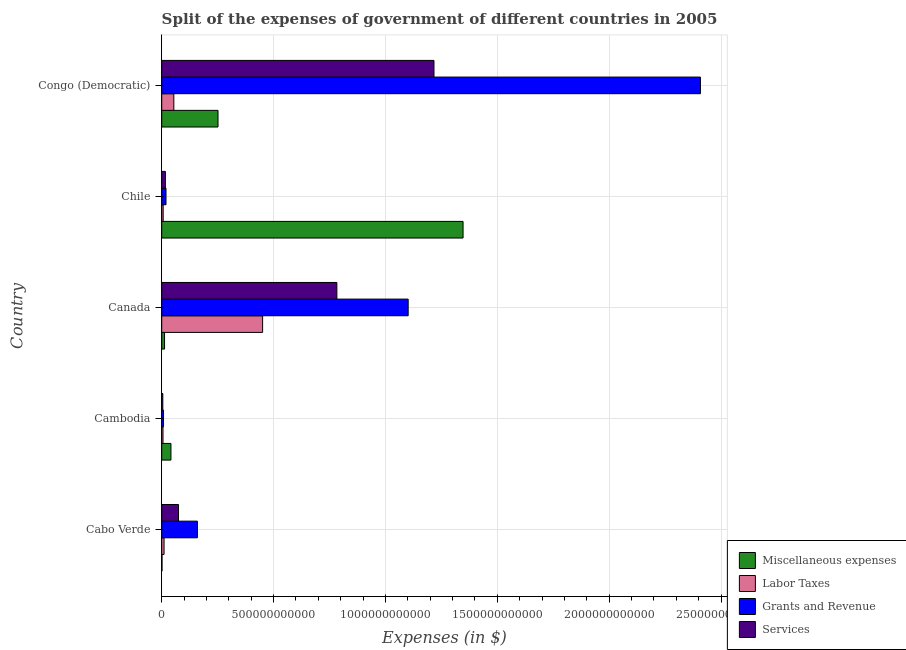How many different coloured bars are there?
Your answer should be very brief. 4. How many bars are there on the 3rd tick from the top?
Keep it short and to the point. 4. How many bars are there on the 3rd tick from the bottom?
Your answer should be very brief. 4. In how many cases, is the number of bars for a given country not equal to the number of legend labels?
Ensure brevity in your answer.  0. What is the amount spent on services in Chile?
Provide a succinct answer. 1.66e+1. Across all countries, what is the maximum amount spent on labor taxes?
Your answer should be compact. 4.51e+11. Across all countries, what is the minimum amount spent on grants and revenue?
Provide a short and direct response. 8.06e+09. In which country was the amount spent on grants and revenue maximum?
Provide a succinct answer. Congo (Democratic). In which country was the amount spent on miscellaneous expenses minimum?
Keep it short and to the point. Cabo Verde. What is the total amount spent on services in the graph?
Offer a terse response. 2.10e+12. What is the difference between the amount spent on grants and revenue in Canada and that in Congo (Democratic)?
Your answer should be compact. -1.31e+12. What is the difference between the amount spent on miscellaneous expenses in Canada and the amount spent on grants and revenue in Cabo Verde?
Your response must be concise. -1.47e+11. What is the average amount spent on labor taxes per country?
Offer a terse response. 1.06e+11. What is the difference between the amount spent on miscellaneous expenses and amount spent on grants and revenue in Cabo Verde?
Provide a succinct answer. -1.58e+11. What is the ratio of the amount spent on grants and revenue in Cambodia to that in Congo (Democratic)?
Keep it short and to the point. 0. Is the amount spent on grants and revenue in Cabo Verde less than that in Congo (Democratic)?
Provide a succinct answer. Yes. Is the difference between the amount spent on labor taxes in Cabo Verde and Congo (Democratic) greater than the difference between the amount spent on services in Cabo Verde and Congo (Democratic)?
Ensure brevity in your answer.  Yes. What is the difference between the highest and the second highest amount spent on miscellaneous expenses?
Your response must be concise. 1.10e+12. What is the difference between the highest and the lowest amount spent on miscellaneous expenses?
Your response must be concise. 1.35e+12. What does the 1st bar from the top in Cabo Verde represents?
Provide a succinct answer. Services. What does the 3rd bar from the bottom in Cambodia represents?
Provide a succinct answer. Grants and Revenue. How many bars are there?
Offer a very short reply. 20. Are all the bars in the graph horizontal?
Your answer should be compact. Yes. What is the difference between two consecutive major ticks on the X-axis?
Your response must be concise. 5.00e+11. Does the graph contain grids?
Offer a terse response. Yes. How many legend labels are there?
Provide a succinct answer. 4. How are the legend labels stacked?
Provide a succinct answer. Vertical. What is the title of the graph?
Provide a succinct answer. Split of the expenses of government of different countries in 2005. What is the label or title of the X-axis?
Provide a short and direct response. Expenses (in $). What is the label or title of the Y-axis?
Your answer should be very brief. Country. What is the Expenses (in $) in Miscellaneous expenses in Cabo Verde?
Offer a very short reply. 1.37e+09. What is the Expenses (in $) in Labor Taxes in Cabo Verde?
Make the answer very short. 1.05e+1. What is the Expenses (in $) of Grants and Revenue in Cabo Verde?
Ensure brevity in your answer.  1.60e+11. What is the Expenses (in $) in Services in Cabo Verde?
Ensure brevity in your answer.  7.51e+1. What is the Expenses (in $) in Miscellaneous expenses in Cambodia?
Your answer should be compact. 4.13e+1. What is the Expenses (in $) of Labor Taxes in Cambodia?
Offer a very short reply. 5.77e+09. What is the Expenses (in $) of Grants and Revenue in Cambodia?
Ensure brevity in your answer.  8.06e+09. What is the Expenses (in $) of Services in Cambodia?
Your answer should be very brief. 4.92e+09. What is the Expenses (in $) in Miscellaneous expenses in Canada?
Give a very brief answer. 1.27e+1. What is the Expenses (in $) of Labor Taxes in Canada?
Your answer should be very brief. 4.51e+11. What is the Expenses (in $) of Grants and Revenue in Canada?
Ensure brevity in your answer.  1.10e+12. What is the Expenses (in $) of Services in Canada?
Your answer should be very brief. 7.83e+11. What is the Expenses (in $) in Miscellaneous expenses in Chile?
Make the answer very short. 1.35e+12. What is the Expenses (in $) of Labor Taxes in Chile?
Offer a very short reply. 6.53e+09. What is the Expenses (in $) of Grants and Revenue in Chile?
Provide a short and direct response. 1.92e+1. What is the Expenses (in $) in Services in Chile?
Give a very brief answer. 1.66e+1. What is the Expenses (in $) in Miscellaneous expenses in Congo (Democratic)?
Offer a very short reply. 2.52e+11. What is the Expenses (in $) in Labor Taxes in Congo (Democratic)?
Give a very brief answer. 5.42e+1. What is the Expenses (in $) of Grants and Revenue in Congo (Democratic)?
Your answer should be compact. 2.41e+12. What is the Expenses (in $) in Services in Congo (Democratic)?
Ensure brevity in your answer.  1.22e+12. Across all countries, what is the maximum Expenses (in $) of Miscellaneous expenses?
Offer a terse response. 1.35e+12. Across all countries, what is the maximum Expenses (in $) of Labor Taxes?
Offer a very short reply. 4.51e+11. Across all countries, what is the maximum Expenses (in $) of Grants and Revenue?
Offer a terse response. 2.41e+12. Across all countries, what is the maximum Expenses (in $) in Services?
Provide a succinct answer. 1.22e+12. Across all countries, what is the minimum Expenses (in $) in Miscellaneous expenses?
Your response must be concise. 1.37e+09. Across all countries, what is the minimum Expenses (in $) in Labor Taxes?
Your response must be concise. 5.77e+09. Across all countries, what is the minimum Expenses (in $) in Grants and Revenue?
Keep it short and to the point. 8.06e+09. Across all countries, what is the minimum Expenses (in $) in Services?
Your response must be concise. 4.92e+09. What is the total Expenses (in $) of Miscellaneous expenses in the graph?
Give a very brief answer. 1.65e+12. What is the total Expenses (in $) of Labor Taxes in the graph?
Keep it short and to the point. 5.28e+11. What is the total Expenses (in $) of Grants and Revenue in the graph?
Ensure brevity in your answer.  3.70e+12. What is the total Expenses (in $) of Services in the graph?
Offer a terse response. 2.10e+12. What is the difference between the Expenses (in $) of Miscellaneous expenses in Cabo Verde and that in Cambodia?
Offer a very short reply. -3.99e+1. What is the difference between the Expenses (in $) of Labor Taxes in Cabo Verde and that in Cambodia?
Provide a short and direct response. 4.74e+09. What is the difference between the Expenses (in $) in Grants and Revenue in Cabo Verde and that in Cambodia?
Keep it short and to the point. 1.52e+11. What is the difference between the Expenses (in $) of Services in Cabo Verde and that in Cambodia?
Ensure brevity in your answer.  7.02e+1. What is the difference between the Expenses (in $) of Miscellaneous expenses in Cabo Verde and that in Canada?
Make the answer very short. -1.13e+1. What is the difference between the Expenses (in $) of Labor Taxes in Cabo Verde and that in Canada?
Ensure brevity in your answer.  -4.40e+11. What is the difference between the Expenses (in $) in Grants and Revenue in Cabo Verde and that in Canada?
Your response must be concise. -9.42e+11. What is the difference between the Expenses (in $) of Services in Cabo Verde and that in Canada?
Provide a short and direct response. -7.08e+11. What is the difference between the Expenses (in $) in Miscellaneous expenses in Cabo Verde and that in Chile?
Offer a very short reply. -1.35e+12. What is the difference between the Expenses (in $) in Labor Taxes in Cabo Verde and that in Chile?
Provide a short and direct response. 3.97e+09. What is the difference between the Expenses (in $) of Grants and Revenue in Cabo Verde and that in Chile?
Keep it short and to the point. 1.40e+11. What is the difference between the Expenses (in $) in Services in Cabo Verde and that in Chile?
Provide a succinct answer. 5.85e+1. What is the difference between the Expenses (in $) in Miscellaneous expenses in Cabo Verde and that in Congo (Democratic)?
Your answer should be very brief. -2.50e+11. What is the difference between the Expenses (in $) in Labor Taxes in Cabo Verde and that in Congo (Democratic)?
Ensure brevity in your answer.  -4.37e+1. What is the difference between the Expenses (in $) of Grants and Revenue in Cabo Verde and that in Congo (Democratic)?
Your response must be concise. -2.25e+12. What is the difference between the Expenses (in $) in Services in Cabo Verde and that in Congo (Democratic)?
Your answer should be compact. -1.14e+12. What is the difference between the Expenses (in $) of Miscellaneous expenses in Cambodia and that in Canada?
Provide a short and direct response. 2.86e+1. What is the difference between the Expenses (in $) of Labor Taxes in Cambodia and that in Canada?
Make the answer very short. -4.45e+11. What is the difference between the Expenses (in $) in Grants and Revenue in Cambodia and that in Canada?
Your answer should be very brief. -1.09e+12. What is the difference between the Expenses (in $) in Services in Cambodia and that in Canada?
Your response must be concise. -7.78e+11. What is the difference between the Expenses (in $) of Miscellaneous expenses in Cambodia and that in Chile?
Keep it short and to the point. -1.31e+12. What is the difference between the Expenses (in $) of Labor Taxes in Cambodia and that in Chile?
Make the answer very short. -7.62e+08. What is the difference between the Expenses (in $) of Grants and Revenue in Cambodia and that in Chile?
Offer a terse response. -1.11e+1. What is the difference between the Expenses (in $) of Services in Cambodia and that in Chile?
Your answer should be compact. -1.17e+1. What is the difference between the Expenses (in $) in Miscellaneous expenses in Cambodia and that in Congo (Democratic)?
Make the answer very short. -2.10e+11. What is the difference between the Expenses (in $) in Labor Taxes in Cambodia and that in Congo (Democratic)?
Offer a terse response. -4.84e+1. What is the difference between the Expenses (in $) in Grants and Revenue in Cambodia and that in Congo (Democratic)?
Offer a terse response. -2.40e+12. What is the difference between the Expenses (in $) of Services in Cambodia and that in Congo (Democratic)?
Provide a succinct answer. -1.21e+12. What is the difference between the Expenses (in $) of Miscellaneous expenses in Canada and that in Chile?
Your answer should be very brief. -1.33e+12. What is the difference between the Expenses (in $) of Labor Taxes in Canada and that in Chile?
Give a very brief answer. 4.44e+11. What is the difference between the Expenses (in $) in Grants and Revenue in Canada and that in Chile?
Keep it short and to the point. 1.08e+12. What is the difference between the Expenses (in $) of Services in Canada and that in Chile?
Offer a terse response. 7.66e+11. What is the difference between the Expenses (in $) in Miscellaneous expenses in Canada and that in Congo (Democratic)?
Give a very brief answer. -2.39e+11. What is the difference between the Expenses (in $) of Labor Taxes in Canada and that in Congo (Democratic)?
Ensure brevity in your answer.  3.97e+11. What is the difference between the Expenses (in $) in Grants and Revenue in Canada and that in Congo (Democratic)?
Your answer should be very brief. -1.31e+12. What is the difference between the Expenses (in $) of Services in Canada and that in Congo (Democratic)?
Your answer should be very brief. -4.34e+11. What is the difference between the Expenses (in $) of Miscellaneous expenses in Chile and that in Congo (Democratic)?
Your answer should be very brief. 1.10e+12. What is the difference between the Expenses (in $) in Labor Taxes in Chile and that in Congo (Democratic)?
Offer a very short reply. -4.76e+1. What is the difference between the Expenses (in $) of Grants and Revenue in Chile and that in Congo (Democratic)?
Offer a terse response. -2.39e+12. What is the difference between the Expenses (in $) in Services in Chile and that in Congo (Democratic)?
Offer a terse response. -1.20e+12. What is the difference between the Expenses (in $) of Miscellaneous expenses in Cabo Verde and the Expenses (in $) of Labor Taxes in Cambodia?
Offer a terse response. -4.40e+09. What is the difference between the Expenses (in $) in Miscellaneous expenses in Cabo Verde and the Expenses (in $) in Grants and Revenue in Cambodia?
Your response must be concise. -6.69e+09. What is the difference between the Expenses (in $) in Miscellaneous expenses in Cabo Verde and the Expenses (in $) in Services in Cambodia?
Offer a terse response. -3.54e+09. What is the difference between the Expenses (in $) of Labor Taxes in Cabo Verde and the Expenses (in $) of Grants and Revenue in Cambodia?
Give a very brief answer. 2.44e+09. What is the difference between the Expenses (in $) of Labor Taxes in Cabo Verde and the Expenses (in $) of Services in Cambodia?
Make the answer very short. 5.59e+09. What is the difference between the Expenses (in $) of Grants and Revenue in Cabo Verde and the Expenses (in $) of Services in Cambodia?
Your answer should be very brief. 1.55e+11. What is the difference between the Expenses (in $) of Miscellaneous expenses in Cabo Verde and the Expenses (in $) of Labor Taxes in Canada?
Make the answer very short. -4.50e+11. What is the difference between the Expenses (in $) of Miscellaneous expenses in Cabo Verde and the Expenses (in $) of Grants and Revenue in Canada?
Your answer should be very brief. -1.10e+12. What is the difference between the Expenses (in $) in Miscellaneous expenses in Cabo Verde and the Expenses (in $) in Services in Canada?
Offer a terse response. -7.82e+11. What is the difference between the Expenses (in $) in Labor Taxes in Cabo Verde and the Expenses (in $) in Grants and Revenue in Canada?
Provide a succinct answer. -1.09e+12. What is the difference between the Expenses (in $) in Labor Taxes in Cabo Verde and the Expenses (in $) in Services in Canada?
Your answer should be very brief. -7.72e+11. What is the difference between the Expenses (in $) in Grants and Revenue in Cabo Verde and the Expenses (in $) in Services in Canada?
Offer a terse response. -6.23e+11. What is the difference between the Expenses (in $) of Miscellaneous expenses in Cabo Verde and the Expenses (in $) of Labor Taxes in Chile?
Your answer should be very brief. -5.16e+09. What is the difference between the Expenses (in $) of Miscellaneous expenses in Cabo Verde and the Expenses (in $) of Grants and Revenue in Chile?
Your answer should be very brief. -1.78e+1. What is the difference between the Expenses (in $) in Miscellaneous expenses in Cabo Verde and the Expenses (in $) in Services in Chile?
Offer a very short reply. -1.52e+1. What is the difference between the Expenses (in $) in Labor Taxes in Cabo Verde and the Expenses (in $) in Grants and Revenue in Chile?
Ensure brevity in your answer.  -8.68e+09. What is the difference between the Expenses (in $) of Labor Taxes in Cabo Verde and the Expenses (in $) of Services in Chile?
Your answer should be very brief. -6.10e+09. What is the difference between the Expenses (in $) in Grants and Revenue in Cabo Verde and the Expenses (in $) in Services in Chile?
Provide a succinct answer. 1.43e+11. What is the difference between the Expenses (in $) in Miscellaneous expenses in Cabo Verde and the Expenses (in $) in Labor Taxes in Congo (Democratic)?
Provide a succinct answer. -5.28e+1. What is the difference between the Expenses (in $) of Miscellaneous expenses in Cabo Verde and the Expenses (in $) of Grants and Revenue in Congo (Democratic)?
Make the answer very short. -2.41e+12. What is the difference between the Expenses (in $) in Miscellaneous expenses in Cabo Verde and the Expenses (in $) in Services in Congo (Democratic)?
Provide a succinct answer. -1.22e+12. What is the difference between the Expenses (in $) in Labor Taxes in Cabo Verde and the Expenses (in $) in Grants and Revenue in Congo (Democratic)?
Offer a terse response. -2.40e+12. What is the difference between the Expenses (in $) in Labor Taxes in Cabo Verde and the Expenses (in $) in Services in Congo (Democratic)?
Your answer should be very brief. -1.21e+12. What is the difference between the Expenses (in $) in Grants and Revenue in Cabo Verde and the Expenses (in $) in Services in Congo (Democratic)?
Keep it short and to the point. -1.06e+12. What is the difference between the Expenses (in $) of Miscellaneous expenses in Cambodia and the Expenses (in $) of Labor Taxes in Canada?
Your answer should be compact. -4.10e+11. What is the difference between the Expenses (in $) of Miscellaneous expenses in Cambodia and the Expenses (in $) of Grants and Revenue in Canada?
Your response must be concise. -1.06e+12. What is the difference between the Expenses (in $) of Miscellaneous expenses in Cambodia and the Expenses (in $) of Services in Canada?
Provide a short and direct response. -7.42e+11. What is the difference between the Expenses (in $) of Labor Taxes in Cambodia and the Expenses (in $) of Grants and Revenue in Canada?
Keep it short and to the point. -1.10e+12. What is the difference between the Expenses (in $) in Labor Taxes in Cambodia and the Expenses (in $) in Services in Canada?
Make the answer very short. -7.77e+11. What is the difference between the Expenses (in $) of Grants and Revenue in Cambodia and the Expenses (in $) of Services in Canada?
Provide a succinct answer. -7.75e+11. What is the difference between the Expenses (in $) in Miscellaneous expenses in Cambodia and the Expenses (in $) in Labor Taxes in Chile?
Your response must be concise. 3.47e+1. What is the difference between the Expenses (in $) in Miscellaneous expenses in Cambodia and the Expenses (in $) in Grants and Revenue in Chile?
Give a very brief answer. 2.21e+1. What is the difference between the Expenses (in $) in Miscellaneous expenses in Cambodia and the Expenses (in $) in Services in Chile?
Make the answer very short. 2.47e+1. What is the difference between the Expenses (in $) in Labor Taxes in Cambodia and the Expenses (in $) in Grants and Revenue in Chile?
Your answer should be very brief. -1.34e+1. What is the difference between the Expenses (in $) in Labor Taxes in Cambodia and the Expenses (in $) in Services in Chile?
Your answer should be compact. -1.08e+1. What is the difference between the Expenses (in $) in Grants and Revenue in Cambodia and the Expenses (in $) in Services in Chile?
Ensure brevity in your answer.  -8.54e+09. What is the difference between the Expenses (in $) in Miscellaneous expenses in Cambodia and the Expenses (in $) in Labor Taxes in Congo (Democratic)?
Offer a terse response. -1.29e+1. What is the difference between the Expenses (in $) of Miscellaneous expenses in Cambodia and the Expenses (in $) of Grants and Revenue in Congo (Democratic)?
Your answer should be compact. -2.37e+12. What is the difference between the Expenses (in $) in Miscellaneous expenses in Cambodia and the Expenses (in $) in Services in Congo (Democratic)?
Provide a succinct answer. -1.18e+12. What is the difference between the Expenses (in $) in Labor Taxes in Cambodia and the Expenses (in $) in Grants and Revenue in Congo (Democratic)?
Your response must be concise. -2.40e+12. What is the difference between the Expenses (in $) of Labor Taxes in Cambodia and the Expenses (in $) of Services in Congo (Democratic)?
Offer a terse response. -1.21e+12. What is the difference between the Expenses (in $) of Grants and Revenue in Cambodia and the Expenses (in $) of Services in Congo (Democratic)?
Ensure brevity in your answer.  -1.21e+12. What is the difference between the Expenses (in $) in Miscellaneous expenses in Canada and the Expenses (in $) in Labor Taxes in Chile?
Your response must be concise. 6.17e+09. What is the difference between the Expenses (in $) of Miscellaneous expenses in Canada and the Expenses (in $) of Grants and Revenue in Chile?
Your answer should be compact. -6.48e+09. What is the difference between the Expenses (in $) of Miscellaneous expenses in Canada and the Expenses (in $) of Services in Chile?
Offer a very short reply. -3.91e+09. What is the difference between the Expenses (in $) of Labor Taxes in Canada and the Expenses (in $) of Grants and Revenue in Chile?
Provide a succinct answer. 4.32e+11. What is the difference between the Expenses (in $) in Labor Taxes in Canada and the Expenses (in $) in Services in Chile?
Your answer should be compact. 4.34e+11. What is the difference between the Expenses (in $) of Grants and Revenue in Canada and the Expenses (in $) of Services in Chile?
Make the answer very short. 1.09e+12. What is the difference between the Expenses (in $) in Miscellaneous expenses in Canada and the Expenses (in $) in Labor Taxes in Congo (Democratic)?
Offer a very short reply. -4.15e+1. What is the difference between the Expenses (in $) of Miscellaneous expenses in Canada and the Expenses (in $) of Grants and Revenue in Congo (Democratic)?
Make the answer very short. -2.40e+12. What is the difference between the Expenses (in $) of Miscellaneous expenses in Canada and the Expenses (in $) of Services in Congo (Democratic)?
Your answer should be compact. -1.20e+12. What is the difference between the Expenses (in $) in Labor Taxes in Canada and the Expenses (in $) in Grants and Revenue in Congo (Democratic)?
Your response must be concise. -1.96e+12. What is the difference between the Expenses (in $) of Labor Taxes in Canada and the Expenses (in $) of Services in Congo (Democratic)?
Provide a succinct answer. -7.66e+11. What is the difference between the Expenses (in $) in Grants and Revenue in Canada and the Expenses (in $) in Services in Congo (Democratic)?
Your answer should be compact. -1.15e+11. What is the difference between the Expenses (in $) in Miscellaneous expenses in Chile and the Expenses (in $) in Labor Taxes in Congo (Democratic)?
Ensure brevity in your answer.  1.29e+12. What is the difference between the Expenses (in $) of Miscellaneous expenses in Chile and the Expenses (in $) of Grants and Revenue in Congo (Democratic)?
Offer a very short reply. -1.06e+12. What is the difference between the Expenses (in $) in Miscellaneous expenses in Chile and the Expenses (in $) in Services in Congo (Democratic)?
Keep it short and to the point. 1.30e+11. What is the difference between the Expenses (in $) in Labor Taxes in Chile and the Expenses (in $) in Grants and Revenue in Congo (Democratic)?
Offer a terse response. -2.40e+12. What is the difference between the Expenses (in $) in Labor Taxes in Chile and the Expenses (in $) in Services in Congo (Democratic)?
Offer a terse response. -1.21e+12. What is the difference between the Expenses (in $) of Grants and Revenue in Chile and the Expenses (in $) of Services in Congo (Democratic)?
Offer a very short reply. -1.20e+12. What is the average Expenses (in $) in Miscellaneous expenses per country?
Give a very brief answer. 3.31e+11. What is the average Expenses (in $) of Labor Taxes per country?
Your answer should be compact. 1.06e+11. What is the average Expenses (in $) of Grants and Revenue per country?
Your answer should be very brief. 7.39e+11. What is the average Expenses (in $) in Services per country?
Your answer should be very brief. 4.19e+11. What is the difference between the Expenses (in $) of Miscellaneous expenses and Expenses (in $) of Labor Taxes in Cabo Verde?
Offer a very short reply. -9.13e+09. What is the difference between the Expenses (in $) of Miscellaneous expenses and Expenses (in $) of Grants and Revenue in Cabo Verde?
Offer a very short reply. -1.58e+11. What is the difference between the Expenses (in $) of Miscellaneous expenses and Expenses (in $) of Services in Cabo Verde?
Give a very brief answer. -7.37e+1. What is the difference between the Expenses (in $) of Labor Taxes and Expenses (in $) of Grants and Revenue in Cabo Verde?
Give a very brief answer. -1.49e+11. What is the difference between the Expenses (in $) in Labor Taxes and Expenses (in $) in Services in Cabo Verde?
Provide a short and direct response. -6.46e+1. What is the difference between the Expenses (in $) of Grants and Revenue and Expenses (in $) of Services in Cabo Verde?
Give a very brief answer. 8.45e+1. What is the difference between the Expenses (in $) in Miscellaneous expenses and Expenses (in $) in Labor Taxes in Cambodia?
Your answer should be very brief. 3.55e+1. What is the difference between the Expenses (in $) of Miscellaneous expenses and Expenses (in $) of Grants and Revenue in Cambodia?
Provide a succinct answer. 3.32e+1. What is the difference between the Expenses (in $) in Miscellaneous expenses and Expenses (in $) in Services in Cambodia?
Offer a terse response. 3.64e+1. What is the difference between the Expenses (in $) in Labor Taxes and Expenses (in $) in Grants and Revenue in Cambodia?
Keep it short and to the point. -2.30e+09. What is the difference between the Expenses (in $) of Labor Taxes and Expenses (in $) of Services in Cambodia?
Provide a short and direct response. 8.52e+08. What is the difference between the Expenses (in $) in Grants and Revenue and Expenses (in $) in Services in Cambodia?
Keep it short and to the point. 3.15e+09. What is the difference between the Expenses (in $) in Miscellaneous expenses and Expenses (in $) in Labor Taxes in Canada?
Keep it short and to the point. -4.38e+11. What is the difference between the Expenses (in $) of Miscellaneous expenses and Expenses (in $) of Grants and Revenue in Canada?
Your answer should be compact. -1.09e+12. What is the difference between the Expenses (in $) in Miscellaneous expenses and Expenses (in $) in Services in Canada?
Offer a very short reply. -7.70e+11. What is the difference between the Expenses (in $) in Labor Taxes and Expenses (in $) in Grants and Revenue in Canada?
Your response must be concise. -6.51e+11. What is the difference between the Expenses (in $) in Labor Taxes and Expenses (in $) in Services in Canada?
Your response must be concise. -3.32e+11. What is the difference between the Expenses (in $) of Grants and Revenue and Expenses (in $) of Services in Canada?
Provide a succinct answer. 3.19e+11. What is the difference between the Expenses (in $) in Miscellaneous expenses and Expenses (in $) in Labor Taxes in Chile?
Keep it short and to the point. 1.34e+12. What is the difference between the Expenses (in $) of Miscellaneous expenses and Expenses (in $) of Grants and Revenue in Chile?
Your response must be concise. 1.33e+12. What is the difference between the Expenses (in $) in Miscellaneous expenses and Expenses (in $) in Services in Chile?
Your response must be concise. 1.33e+12. What is the difference between the Expenses (in $) of Labor Taxes and Expenses (in $) of Grants and Revenue in Chile?
Ensure brevity in your answer.  -1.27e+1. What is the difference between the Expenses (in $) in Labor Taxes and Expenses (in $) in Services in Chile?
Give a very brief answer. -1.01e+1. What is the difference between the Expenses (in $) in Grants and Revenue and Expenses (in $) in Services in Chile?
Offer a very short reply. 2.58e+09. What is the difference between the Expenses (in $) in Miscellaneous expenses and Expenses (in $) in Labor Taxes in Congo (Democratic)?
Your answer should be very brief. 1.97e+11. What is the difference between the Expenses (in $) of Miscellaneous expenses and Expenses (in $) of Grants and Revenue in Congo (Democratic)?
Provide a short and direct response. -2.16e+12. What is the difference between the Expenses (in $) in Miscellaneous expenses and Expenses (in $) in Services in Congo (Democratic)?
Make the answer very short. -9.65e+11. What is the difference between the Expenses (in $) of Labor Taxes and Expenses (in $) of Grants and Revenue in Congo (Democratic)?
Your answer should be very brief. -2.35e+12. What is the difference between the Expenses (in $) of Labor Taxes and Expenses (in $) of Services in Congo (Democratic)?
Give a very brief answer. -1.16e+12. What is the difference between the Expenses (in $) of Grants and Revenue and Expenses (in $) of Services in Congo (Democratic)?
Provide a succinct answer. 1.19e+12. What is the ratio of the Expenses (in $) in Labor Taxes in Cabo Verde to that in Cambodia?
Ensure brevity in your answer.  1.82. What is the ratio of the Expenses (in $) of Grants and Revenue in Cabo Verde to that in Cambodia?
Offer a very short reply. 19.79. What is the ratio of the Expenses (in $) in Services in Cabo Verde to that in Cambodia?
Provide a succinct answer. 15.28. What is the ratio of the Expenses (in $) of Miscellaneous expenses in Cabo Verde to that in Canada?
Provide a succinct answer. 0.11. What is the ratio of the Expenses (in $) in Labor Taxes in Cabo Verde to that in Canada?
Give a very brief answer. 0.02. What is the ratio of the Expenses (in $) of Grants and Revenue in Cabo Verde to that in Canada?
Provide a short and direct response. 0.14. What is the ratio of the Expenses (in $) in Services in Cabo Verde to that in Canada?
Your answer should be compact. 0.1. What is the ratio of the Expenses (in $) of Miscellaneous expenses in Cabo Verde to that in Chile?
Make the answer very short. 0. What is the ratio of the Expenses (in $) in Labor Taxes in Cabo Verde to that in Chile?
Your answer should be compact. 1.61. What is the ratio of the Expenses (in $) of Grants and Revenue in Cabo Verde to that in Chile?
Keep it short and to the point. 8.32. What is the ratio of the Expenses (in $) of Services in Cabo Verde to that in Chile?
Your response must be concise. 4.52. What is the ratio of the Expenses (in $) in Miscellaneous expenses in Cabo Verde to that in Congo (Democratic)?
Offer a terse response. 0.01. What is the ratio of the Expenses (in $) in Labor Taxes in Cabo Verde to that in Congo (Democratic)?
Offer a very short reply. 0.19. What is the ratio of the Expenses (in $) in Grants and Revenue in Cabo Verde to that in Congo (Democratic)?
Ensure brevity in your answer.  0.07. What is the ratio of the Expenses (in $) in Services in Cabo Verde to that in Congo (Democratic)?
Make the answer very short. 0.06. What is the ratio of the Expenses (in $) of Miscellaneous expenses in Cambodia to that in Canada?
Offer a very short reply. 3.25. What is the ratio of the Expenses (in $) of Labor Taxes in Cambodia to that in Canada?
Your answer should be compact. 0.01. What is the ratio of the Expenses (in $) in Grants and Revenue in Cambodia to that in Canada?
Your answer should be compact. 0.01. What is the ratio of the Expenses (in $) of Services in Cambodia to that in Canada?
Your answer should be very brief. 0.01. What is the ratio of the Expenses (in $) in Miscellaneous expenses in Cambodia to that in Chile?
Offer a very short reply. 0.03. What is the ratio of the Expenses (in $) in Labor Taxes in Cambodia to that in Chile?
Provide a short and direct response. 0.88. What is the ratio of the Expenses (in $) of Grants and Revenue in Cambodia to that in Chile?
Your answer should be compact. 0.42. What is the ratio of the Expenses (in $) of Services in Cambodia to that in Chile?
Your answer should be compact. 0.3. What is the ratio of the Expenses (in $) of Miscellaneous expenses in Cambodia to that in Congo (Democratic)?
Keep it short and to the point. 0.16. What is the ratio of the Expenses (in $) in Labor Taxes in Cambodia to that in Congo (Democratic)?
Provide a short and direct response. 0.11. What is the ratio of the Expenses (in $) of Grants and Revenue in Cambodia to that in Congo (Democratic)?
Provide a short and direct response. 0. What is the ratio of the Expenses (in $) of Services in Cambodia to that in Congo (Democratic)?
Give a very brief answer. 0. What is the ratio of the Expenses (in $) in Miscellaneous expenses in Canada to that in Chile?
Your response must be concise. 0.01. What is the ratio of the Expenses (in $) in Labor Taxes in Canada to that in Chile?
Offer a terse response. 69.06. What is the ratio of the Expenses (in $) of Grants and Revenue in Canada to that in Chile?
Offer a terse response. 57.43. What is the ratio of the Expenses (in $) in Services in Canada to that in Chile?
Your answer should be very brief. 47.16. What is the ratio of the Expenses (in $) of Miscellaneous expenses in Canada to that in Congo (Democratic)?
Your response must be concise. 0.05. What is the ratio of the Expenses (in $) in Labor Taxes in Canada to that in Congo (Democratic)?
Offer a very short reply. 8.33. What is the ratio of the Expenses (in $) of Grants and Revenue in Canada to that in Congo (Democratic)?
Keep it short and to the point. 0.46. What is the ratio of the Expenses (in $) in Services in Canada to that in Congo (Democratic)?
Ensure brevity in your answer.  0.64. What is the ratio of the Expenses (in $) in Miscellaneous expenses in Chile to that in Congo (Democratic)?
Keep it short and to the point. 5.35. What is the ratio of the Expenses (in $) in Labor Taxes in Chile to that in Congo (Democratic)?
Your answer should be compact. 0.12. What is the ratio of the Expenses (in $) in Grants and Revenue in Chile to that in Congo (Democratic)?
Provide a short and direct response. 0.01. What is the ratio of the Expenses (in $) in Services in Chile to that in Congo (Democratic)?
Offer a terse response. 0.01. What is the difference between the highest and the second highest Expenses (in $) in Miscellaneous expenses?
Provide a succinct answer. 1.10e+12. What is the difference between the highest and the second highest Expenses (in $) in Labor Taxes?
Your answer should be very brief. 3.97e+11. What is the difference between the highest and the second highest Expenses (in $) of Grants and Revenue?
Your answer should be compact. 1.31e+12. What is the difference between the highest and the second highest Expenses (in $) in Services?
Keep it short and to the point. 4.34e+11. What is the difference between the highest and the lowest Expenses (in $) in Miscellaneous expenses?
Keep it short and to the point. 1.35e+12. What is the difference between the highest and the lowest Expenses (in $) of Labor Taxes?
Your response must be concise. 4.45e+11. What is the difference between the highest and the lowest Expenses (in $) in Grants and Revenue?
Your answer should be compact. 2.40e+12. What is the difference between the highest and the lowest Expenses (in $) in Services?
Your answer should be very brief. 1.21e+12. 